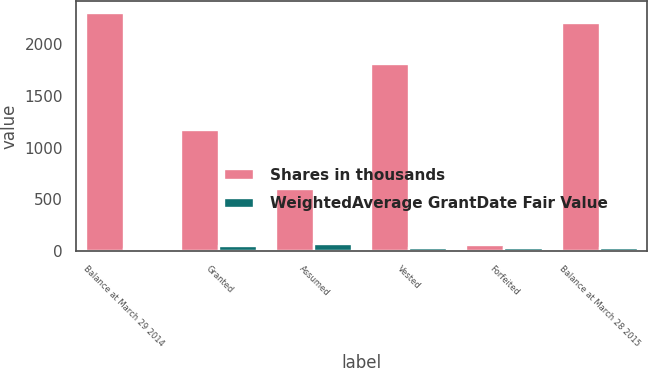<chart> <loc_0><loc_0><loc_500><loc_500><stacked_bar_chart><ecel><fcel>Balance at March 29 2014<fcel>Granted<fcel>Assumed<fcel>Vested<fcel>Forfeited<fcel>Balance at March 28 2015<nl><fcel>Shares in thousands<fcel>2298<fcel>1166<fcel>599<fcel>1806<fcel>55<fcel>2202<nl><fcel>WeightedAverage GrantDate Fair Value<fcel>19.44<fcel>45.61<fcel>66.36<fcel>26.96<fcel>26.75<fcel>34.29<nl></chart> 